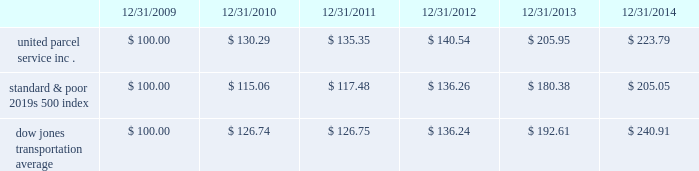Shareowner return performance graph the following performance graph and related information shall not be deemed 201csoliciting material 201d or to be 201cfiled 201d with the sec , nor shall such information be incorporated by reference into any future filing under the securities act of 1933 or securities exchange act of 1934 , each as amended , except to the extent that the company specifically incorporates such information by reference into such filing .
The following graph shows a five year comparison of cumulative total shareowners 2019 returns for our class b common stock , the standard & poor 2019s 500 index , and the dow jones transportation average .
The comparison of the total cumulative return on investment , which is the change in the quarterly stock price plus reinvested dividends for each of the quarterly periods , assumes that $ 100 was invested on december 31 , 2009 in the standard & poor 2019s 500 index , the dow jones transportation average , and our class b common stock. .

What is the roi of an investment in s&p500 from 2010 to 2012? 
Computations: ((136.26 - 115.06) / 115.06)
Answer: 0.18425. 